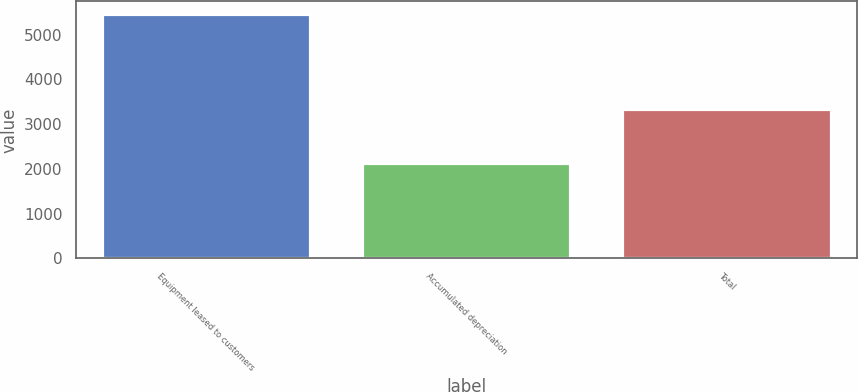<chart> <loc_0><loc_0><loc_500><loc_500><bar_chart><fcel>Equipment leased to customers<fcel>Accumulated depreciation<fcel>Total<nl><fcel>5467<fcel>2134<fcel>3333<nl></chart> 